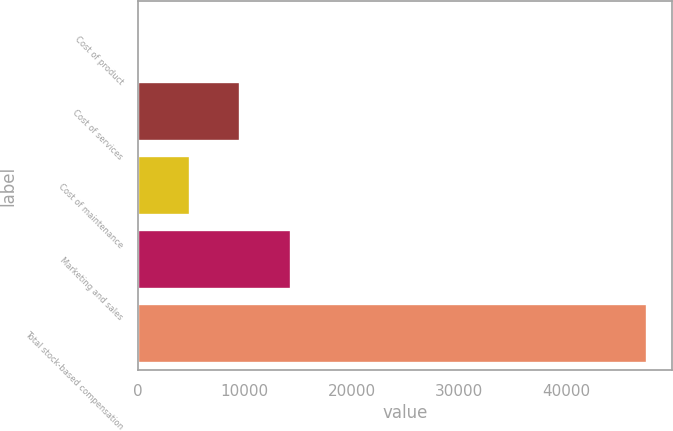<chart> <loc_0><loc_0><loc_500><loc_500><bar_chart><fcel>Cost of product<fcel>Cost of services<fcel>Cost of maintenance<fcel>Marketing and sales<fcel>Total stock-based compensation<nl><fcel>99<fcel>9591.4<fcel>4845.2<fcel>14337.6<fcel>47561<nl></chart> 